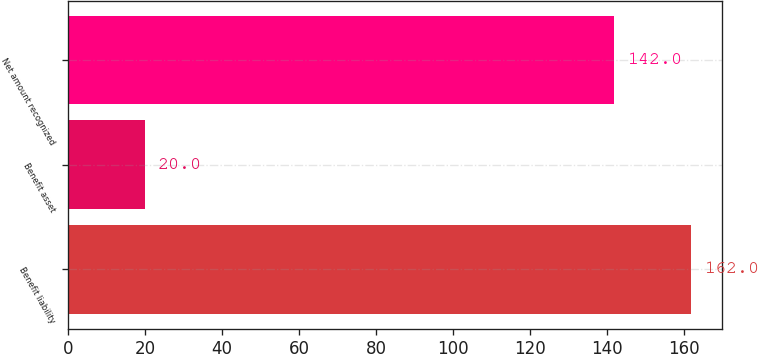<chart> <loc_0><loc_0><loc_500><loc_500><bar_chart><fcel>Benefit liability<fcel>Benefit asset<fcel>Net amount recognized<nl><fcel>162<fcel>20<fcel>142<nl></chart> 